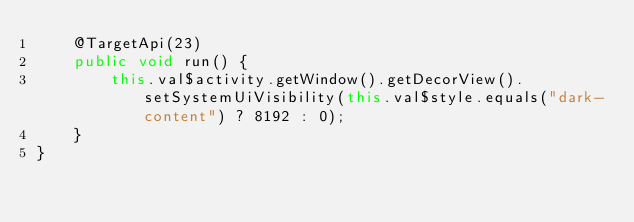<code> <loc_0><loc_0><loc_500><loc_500><_Java_>    @TargetApi(23)
    public void run() {
        this.val$activity.getWindow().getDecorView().setSystemUiVisibility(this.val$style.equals("dark-content") ? 8192 : 0);
    }
}
</code> 